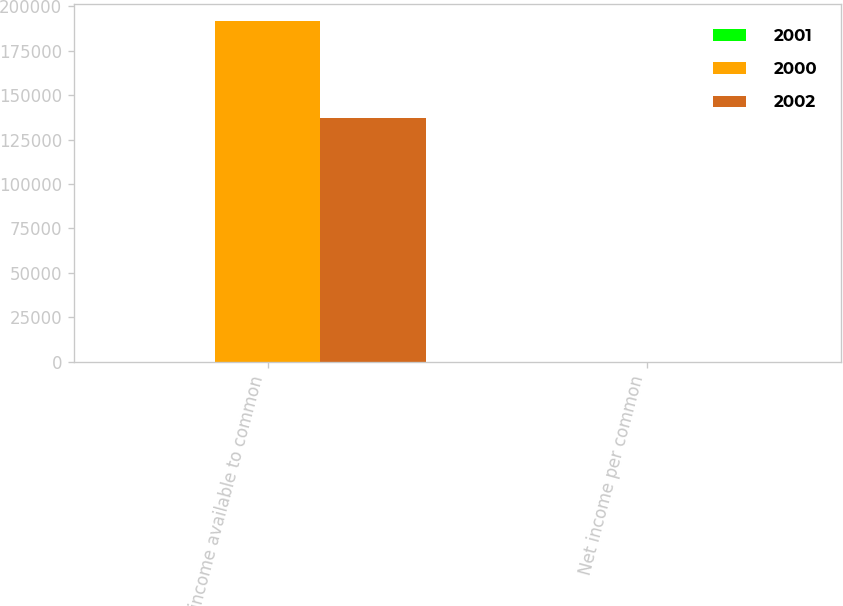<chart> <loc_0><loc_0><loc_500><loc_500><stacked_bar_chart><ecel><fcel>Net income available to common<fcel>Net income per common<nl><fcel>2001<fcel>3.355<fcel>4.58<nl><fcel>2000<fcel>191973<fcel>2.08<nl><fcel>2002<fcel>137425<fcel>1.89<nl></chart> 